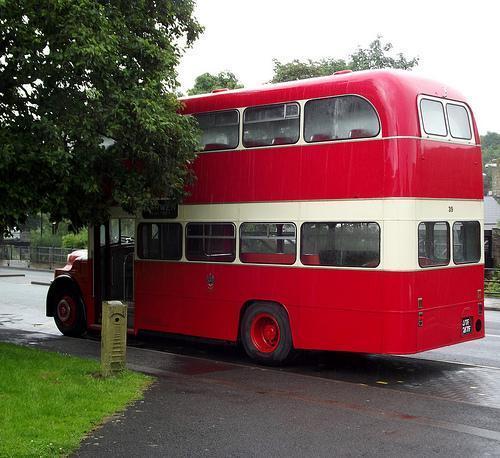How many busses are there?
Give a very brief answer. 1. 